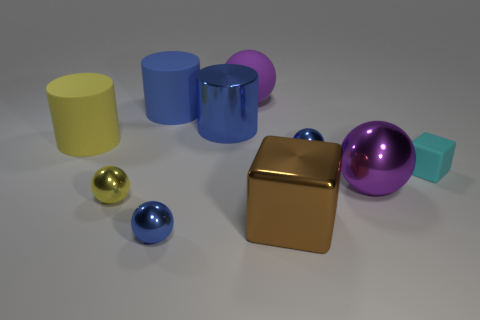Is the size of the blue ball behind the yellow metal object the same as the brown object?
Ensure brevity in your answer.  No. There is another metallic cylinder that is the same size as the yellow cylinder; what is its color?
Make the answer very short. Blue. There is a big sphere that is behind the big ball that is in front of the large yellow rubber thing; are there any tiny cyan matte objects behind it?
Provide a succinct answer. No. What is the material of the tiny blue object that is behind the large brown thing?
Your answer should be compact. Metal. Do the large brown metallic object and the matte thing on the right side of the rubber sphere have the same shape?
Ensure brevity in your answer.  Yes. Are there an equal number of small spheres that are left of the big purple rubber object and small cyan matte objects that are behind the big blue shiny cylinder?
Offer a terse response. No. What number of other objects are the same material as the brown thing?
Provide a succinct answer. 5. How many matte things are tiny blocks or big yellow cylinders?
Your answer should be compact. 2. There is a purple object that is in front of the large blue metal object; does it have the same shape as the cyan thing?
Offer a very short reply. No. Are there more tiny metallic things that are right of the metallic cylinder than large gray rubber cylinders?
Provide a short and direct response. Yes. 